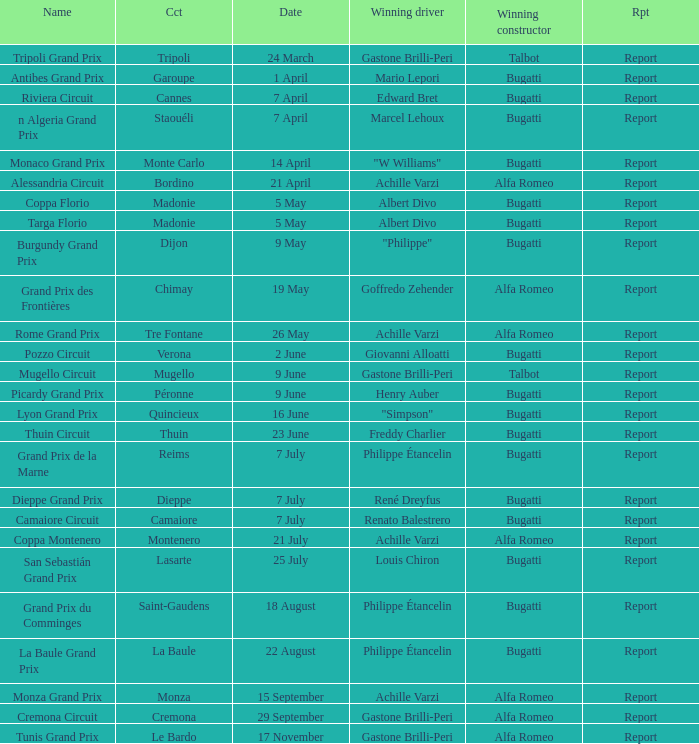What Circuit has a Date of 25 july? Lasarte. Help me parse the entirety of this table. {'header': ['Name', 'Cct', 'Date', 'Winning driver', 'Winning constructor', 'Rpt'], 'rows': [['Tripoli Grand Prix', 'Tripoli', '24 March', 'Gastone Brilli-Peri', 'Talbot', 'Report'], ['Antibes Grand Prix', 'Garoupe', '1 April', 'Mario Lepori', 'Bugatti', 'Report'], ['Riviera Circuit', 'Cannes', '7 April', 'Edward Bret', 'Bugatti', 'Report'], ['n Algeria Grand Prix', 'Staouéli', '7 April', 'Marcel Lehoux', 'Bugatti', 'Report'], ['Monaco Grand Prix', 'Monte Carlo', '14 April', '"W Williams"', 'Bugatti', 'Report'], ['Alessandria Circuit', 'Bordino', '21 April', 'Achille Varzi', 'Alfa Romeo', 'Report'], ['Coppa Florio', 'Madonie', '5 May', 'Albert Divo', 'Bugatti', 'Report'], ['Targa Florio', 'Madonie', '5 May', 'Albert Divo', 'Bugatti', 'Report'], ['Burgundy Grand Prix', 'Dijon', '9 May', '"Philippe"', 'Bugatti', 'Report'], ['Grand Prix des Frontières', 'Chimay', '19 May', 'Goffredo Zehender', 'Alfa Romeo', 'Report'], ['Rome Grand Prix', 'Tre Fontane', '26 May', 'Achille Varzi', 'Alfa Romeo', 'Report'], ['Pozzo Circuit', 'Verona', '2 June', 'Giovanni Alloatti', 'Bugatti', 'Report'], ['Mugello Circuit', 'Mugello', '9 June', 'Gastone Brilli-Peri', 'Talbot', 'Report'], ['Picardy Grand Prix', 'Péronne', '9 June', 'Henry Auber', 'Bugatti', 'Report'], ['Lyon Grand Prix', 'Quincieux', '16 June', '"Simpson"', 'Bugatti', 'Report'], ['Thuin Circuit', 'Thuin', '23 June', 'Freddy Charlier', 'Bugatti', 'Report'], ['Grand Prix de la Marne', 'Reims', '7 July', 'Philippe Étancelin', 'Bugatti', 'Report'], ['Dieppe Grand Prix', 'Dieppe', '7 July', 'René Dreyfus', 'Bugatti', 'Report'], ['Camaiore Circuit', 'Camaiore', '7 July', 'Renato Balestrero', 'Bugatti', 'Report'], ['Coppa Montenero', 'Montenero', '21 July', 'Achille Varzi', 'Alfa Romeo', 'Report'], ['San Sebastián Grand Prix', 'Lasarte', '25 July', 'Louis Chiron', 'Bugatti', 'Report'], ['Grand Prix du Comminges', 'Saint-Gaudens', '18 August', 'Philippe Étancelin', 'Bugatti', 'Report'], ['La Baule Grand Prix', 'La Baule', '22 August', 'Philippe Étancelin', 'Bugatti', 'Report'], ['Monza Grand Prix', 'Monza', '15 September', 'Achille Varzi', 'Alfa Romeo', 'Report'], ['Cremona Circuit', 'Cremona', '29 September', 'Gastone Brilli-Peri', 'Alfa Romeo', 'Report'], ['Tunis Grand Prix', 'Le Bardo', '17 November', 'Gastone Brilli-Peri', 'Alfa Romeo', 'Report']]} 